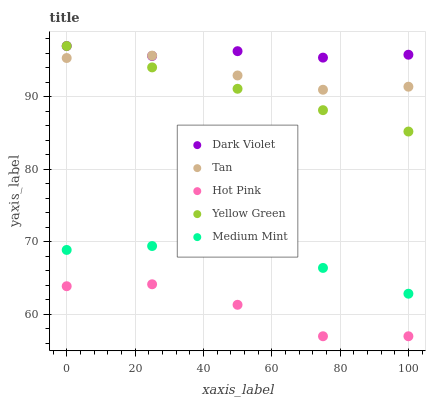Does Hot Pink have the minimum area under the curve?
Answer yes or no. Yes. Does Dark Violet have the maximum area under the curve?
Answer yes or no. Yes. Does Tan have the minimum area under the curve?
Answer yes or no. No. Does Tan have the maximum area under the curve?
Answer yes or no. No. Is Yellow Green the smoothest?
Answer yes or no. Yes. Is Hot Pink the roughest?
Answer yes or no. Yes. Is Tan the smoothest?
Answer yes or no. No. Is Tan the roughest?
Answer yes or no. No. Does Hot Pink have the lowest value?
Answer yes or no. Yes. Does Tan have the lowest value?
Answer yes or no. No. Does Dark Violet have the highest value?
Answer yes or no. Yes. Does Tan have the highest value?
Answer yes or no. No. Is Medium Mint less than Yellow Green?
Answer yes or no. Yes. Is Tan greater than Hot Pink?
Answer yes or no. Yes. Does Dark Violet intersect Tan?
Answer yes or no. Yes. Is Dark Violet less than Tan?
Answer yes or no. No. Is Dark Violet greater than Tan?
Answer yes or no. No. Does Medium Mint intersect Yellow Green?
Answer yes or no. No. 